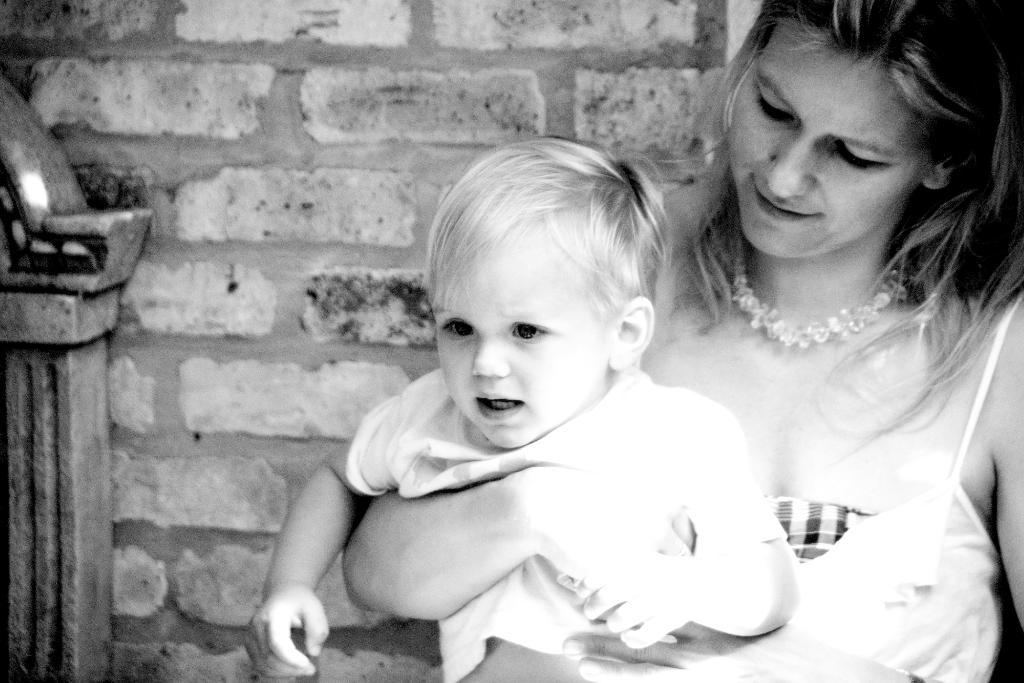What is the color scheme of the image? The image is black and white. Who is present in the image? There is a woman in the image. What is the woman doing in the image? The woman is holding a boy. What can be seen in the background of the image? There is a wall in the background of the image. What type of drum is the woman playing in the image? There is no drum present in the image; it features a woman holding a boy. Is the woman in a prison in the image? There is no indication of a prison or any confinement in the image, which shows a woman holding a boy with a wall in the background. 